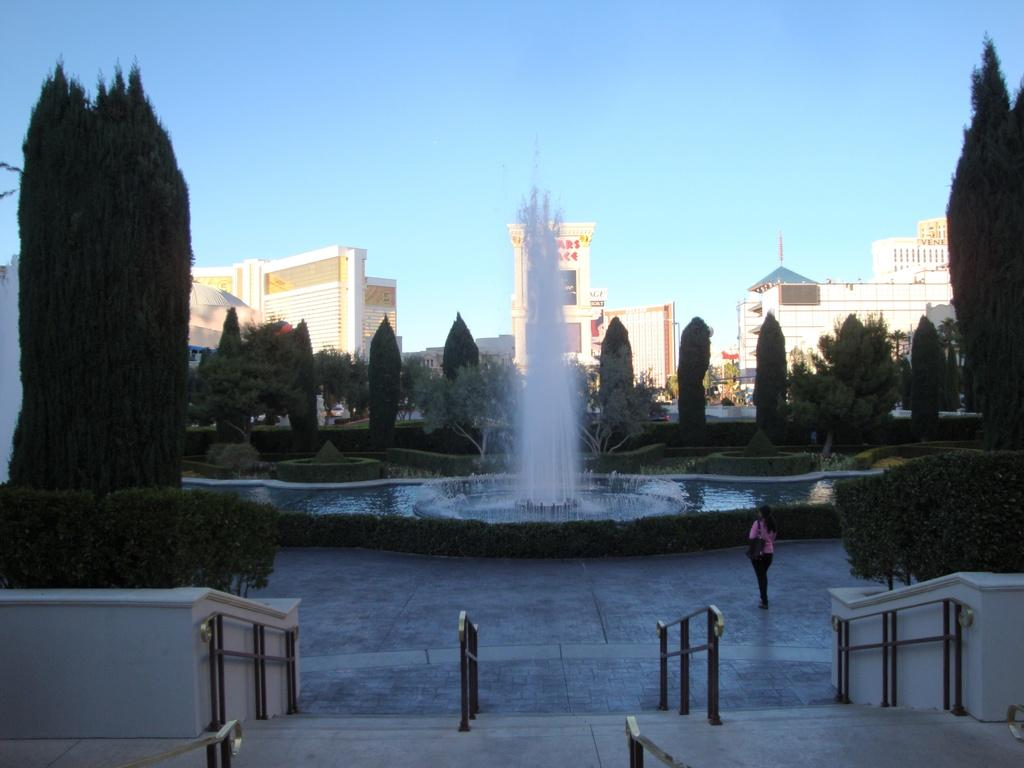Who is present in the image? There is a woman in the image. What architectural feature can be seen in the image? There is a staircase in the image. What safety feature is present near the staircase? There is a railing in the image. What type of natural environment is visible in the image? Trees, water, and grass are present in the image. What man-made structure can be seen in the image? Buildings are visible in the image. What is the outdoor setting like in the image? The image features a fountain, plants, and the sky. What type of flooring is present in the image? There is a floor in the image. What type of screw can be seen joining the buildings in the image? There is no screw visible in the image; the buildings are not being joined together. What type of alley can be seen behind the woman in the image? There is no alley present in the image; the woman is standing in an outdoor setting with trees, water, and a fountain. 